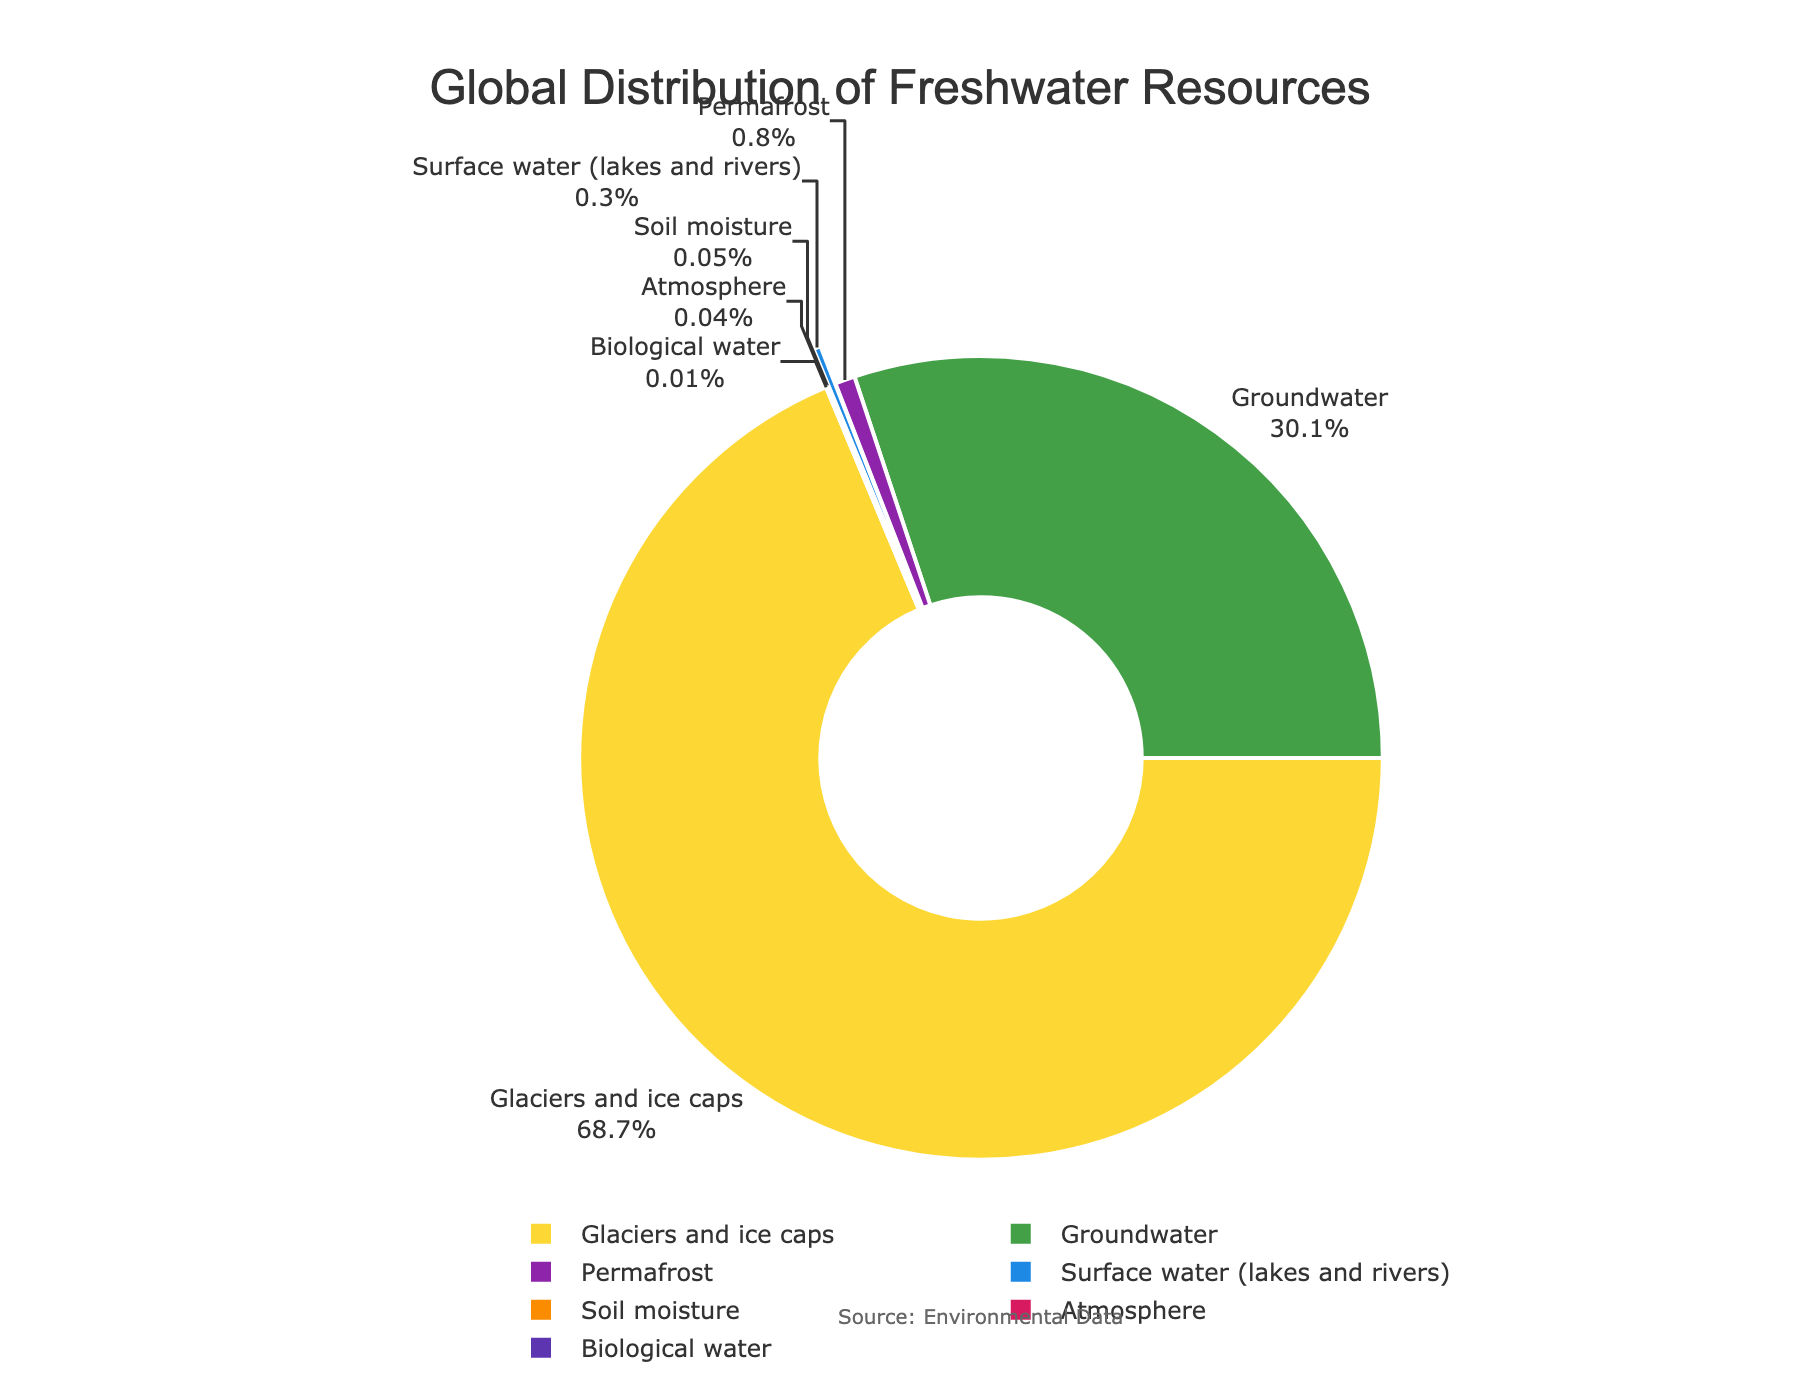Which type of freshwater resource has the highest percentage? The pie chart shows that the segment representing "Glaciers and ice caps" is the largest.
Answer: Glaciers and ice caps What is the combined percentage of Surface water and Groundwater? By adding the percentages of "Surface water (lakes and rivers)" (0.3%) and "Groundwater" (30.1%), we get 0.3% + 30.1% = 30.4%.
Answer: 30.4% How does the percentage of Permafrost compare to Soil moisture? The percentage of "Permafrost" is 0.8%, which is higher than the percentage of "Soil moisture" at 0.05%.
Answer: Permafrost is higher What percentage of freshwater resources is categorized as Biological water? The segment representing "Biological water" is marked with a 0.01% label.
Answer: 0.01% Which segment is represented by red color and what's its percentage? The pie chart uses colors to represent different types of freshwater resources. By identifying the red-colored segment, which is "Atmosphere", we see it is 0.04%.
Answer: Atmosphere, 0.04% What is the sum of the percentages of the three smallest types of freshwater resources? The smallest segments are "Biological water" (0.01%), "Soil moisture" (0.05%), and "Atmosphere" (0.04%). Adding them together, 0.01% + 0.05% + 0.04% = 0.1%.
Answer: 0.1% If the segment for Glaciers and ice caps was split into four equal parts, what would be the percentage of each part? "Glaciers and ice caps" are 68.7%. Dividing this by 4 gives 68.7% / 4 = 17.175%.
Answer: 17.175% How many types of freshwater resources are visually represented in the pie chart? By counting the number of distinct segments in the pie chart, there are 7 types of freshwater resources.
Answer: 7 